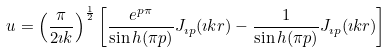Convert formula to latex. <formula><loc_0><loc_0><loc_500><loc_500>u = \left ( \frac { \pi } { 2 \imath k } \right ) ^ { \frac { 1 } { 2 } } \left [ \frac { e ^ { p \pi } } { \sin h ( \pi p ) } J _ { \imath p } ( \imath k r ) - \frac { 1 } { \sin h ( \pi p ) } J _ { \imath p } ( \imath k r ) \right ]</formula> 